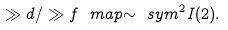Convert formula to latex. <formula><loc_0><loc_0><loc_500><loc_500>\gg d / \gg f \ m a p { \sim } \ s y m ^ { 2 } I ( 2 ) .</formula> 